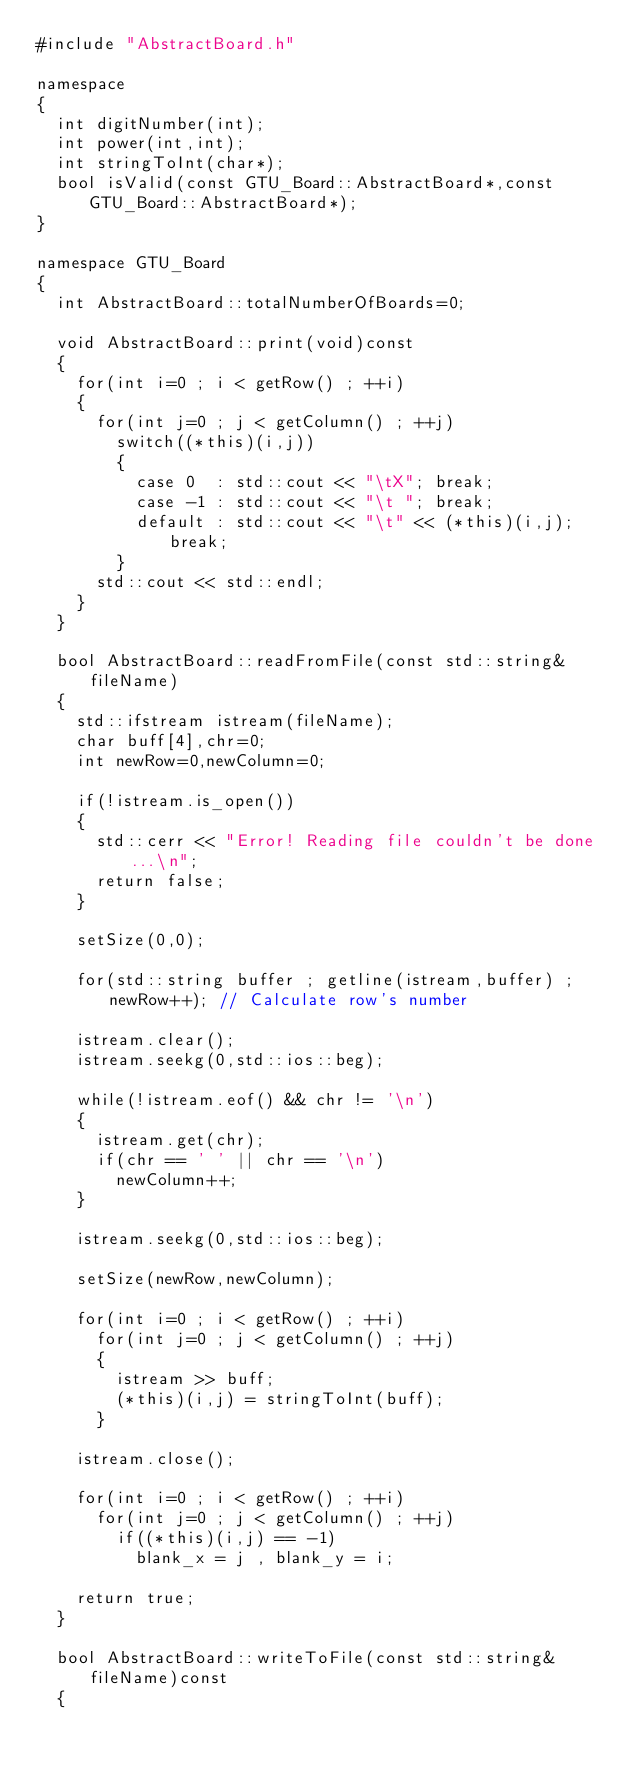Convert code to text. <code><loc_0><loc_0><loc_500><loc_500><_C++_>#include "AbstractBoard.h"

namespace
{
	int digitNumber(int);
	int power(int,int);
	int stringToInt(char*);
	bool isValid(const GTU_Board::AbstractBoard*,const GTU_Board::AbstractBoard*);
}

namespace GTU_Board
{
	int AbstractBoard::totalNumberOfBoards=0;

	void AbstractBoard::print(void)const
	{
		for(int i=0 ; i < getRow() ; ++i)
		{
			for(int j=0 ; j < getColumn() ; ++j)
				switch((*this)(i,j))
				{
					case 0	: std::cout << "\tX";	break;
					case -1	: std::cout << "\t ";	break;
					default	: std::cout << "\t" << (*this)(i,j);	break;
				}
			std::cout << std::endl;
		}
	}

	bool AbstractBoard::readFromFile(const std::string& fileName)
	{
		std::ifstream istream(fileName);
		char buff[4],chr=0;
		int newRow=0,newColumn=0;

		if(!istream.is_open())
		{
			std::cerr << "Error! Reading file couldn't be done...\n";
			return false;
		}

		setSize(0,0);

		for(std::string buffer ; getline(istream,buffer) ; newRow++);	// Calculate row's number

		istream.clear();
		istream.seekg(0,std::ios::beg);

		while(!istream.eof() && chr != '\n')
		{
			istream.get(chr);
			if(chr == ' ' || chr == '\n')
				newColumn++;
		}

		istream.seekg(0,std::ios::beg);

		setSize(newRow,newColumn);

		for(int i=0 ; i < getRow() ; ++i)
			for(int j=0 ; j < getColumn() ; ++j)
			{
				istream >> buff;
				(*this)(i,j) = stringToInt(buff);
			}

		istream.close();

		for(int i=0 ; i < getRow() ; ++i)
			for(int j=0 ; j < getColumn() ; ++j)
				if((*this)(i,j) == -1)
					blank_x = j , blank_y = i;

		return true;
	}

	bool AbstractBoard::writeToFile(const std::string& fileName)const
	{</code> 